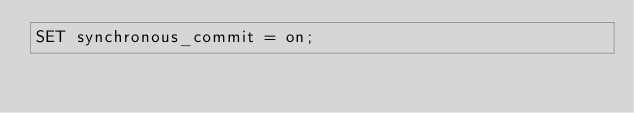<code> <loc_0><loc_0><loc_500><loc_500><_SQL_>SET synchronous_commit = on;
</code> 